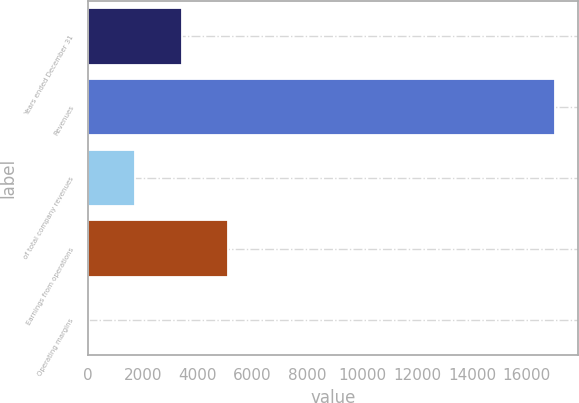<chart> <loc_0><loc_0><loc_500><loc_500><bar_chart><fcel>Years ended December 31<fcel>Revenues<fcel>of total company revenues<fcel>Earnings from operations<fcel>Operating margins<nl><fcel>3415.44<fcel>17018<fcel>1715.12<fcel>5115.76<fcel>14.8<nl></chart> 